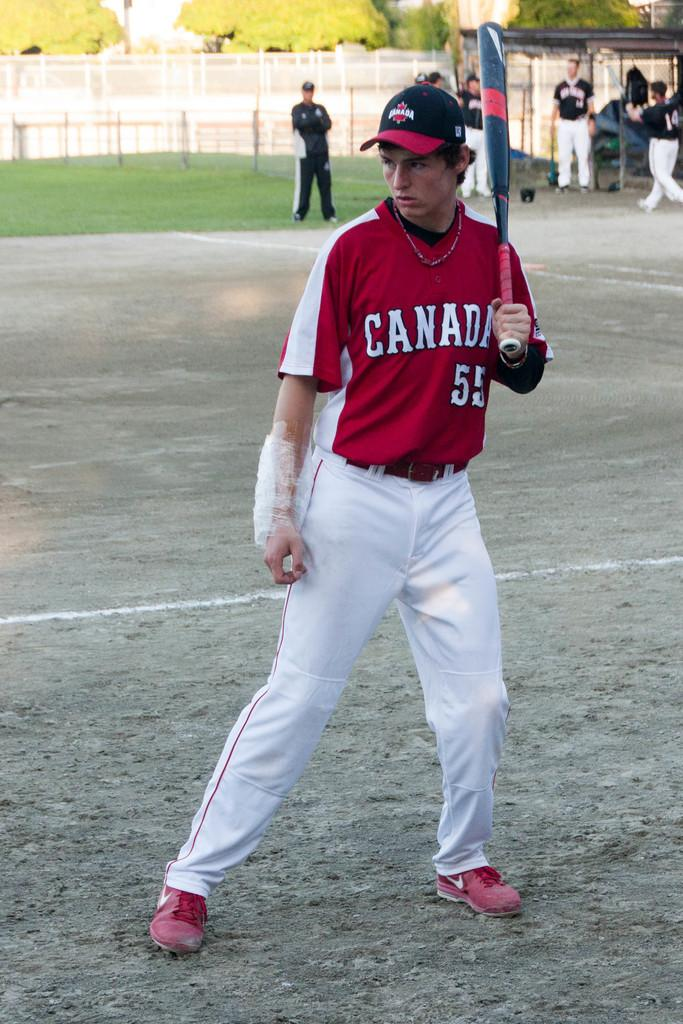<image>
Render a clear and concise summary of the photo. a person in a Canada number 55 jersey with a bat in hand 